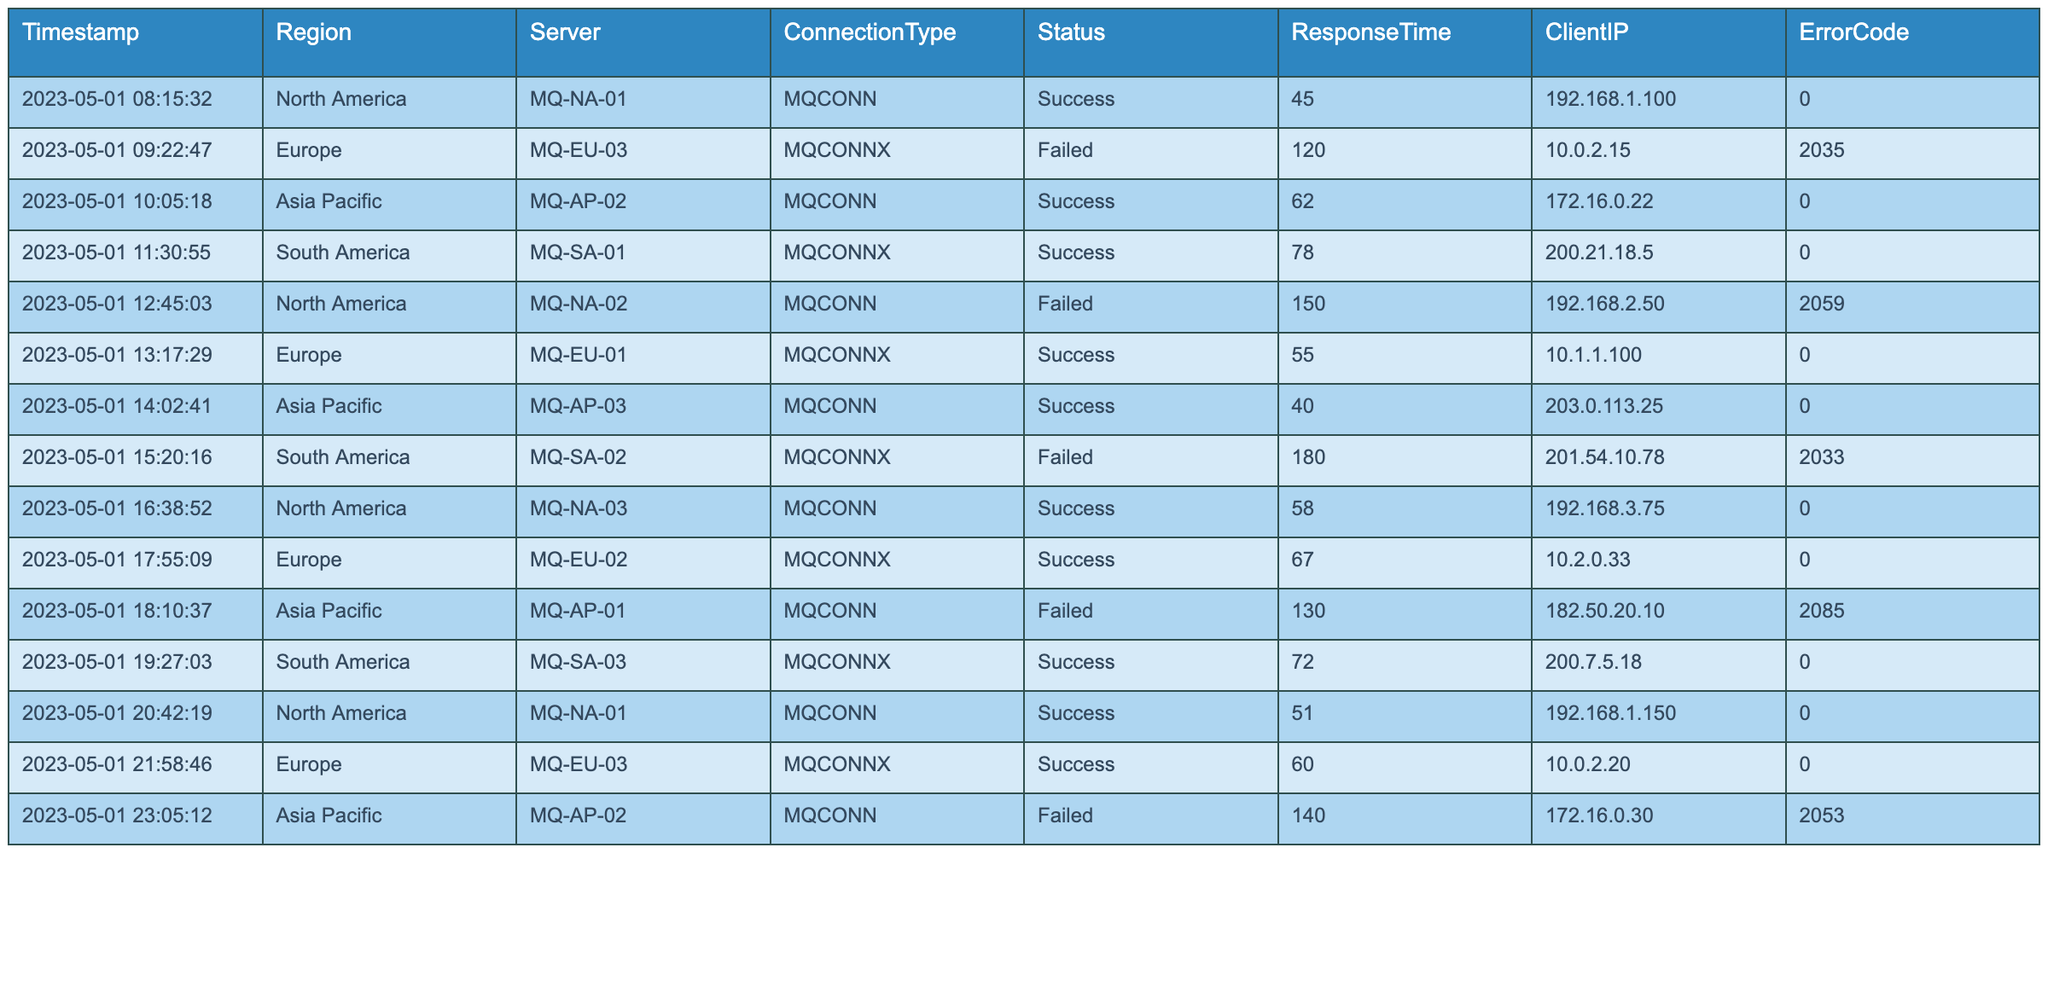What is the total number of successful connections across all regions? Count the rows in the table where Status is "Success". There are 10 successful connections listed in the data.
Answer: 10 What was the maximum response time recorded in the logs? Look for the highest value in the ResponseTime column. The maximum value is 180 milliseconds in South America for the server MQ-SA-02.
Answer: 180 Which server in the Asia Pacific region had the lowest response time? From the Asia Pacific entries, compare the ResponseTime values of MQ-AP-02 (62), MQ-AP-03 (40), and MQ-AP-01 (130). The lowest is for MQ-AP-03 with a response time of 40 milliseconds.
Answer: MQ-AP-03 Was there a successful connection logged from the client IP 203.0.113.25? Check the entries for the client IP 203.0.113.25 in the table. There was a successful connection from this IP.
Answer: Yes What is the average response time of failed connections? Identify rows where Status is "Failed" and sum their response times (120 + 150 + 180 + 130 = 580). There are 4 failed connections, so the average is 580/4 = 145 seconds.
Answer: 145 How many connections were logged from North America? Count the rows in the table where the Region is "North America". There are 5 connections logged from this region.
Answer: 5 Do any servers in Europe show a failure in their connection logs? Review the Server connections in Europe for any instances of "Failed" in the Status column. Yes, MQ-EU-03 had a failed connection.
Answer: Yes What is the total number of connections recorded for the Asia Pacific region? Count the entries where the Region is "Asia Pacific". There are 3 connections logged from this region.
Answer: 3 What percentage of total connections ended in failure? Count total connections (16) and failed connections (6), then calculate (6/16)*100 = 37.5%.
Answer: 37.5% What was the response time of the first connection log entry? Identify the first entry in the logs and check the ResponseTime value. The first entry has a response time of 45 milliseconds.
Answer: 45 